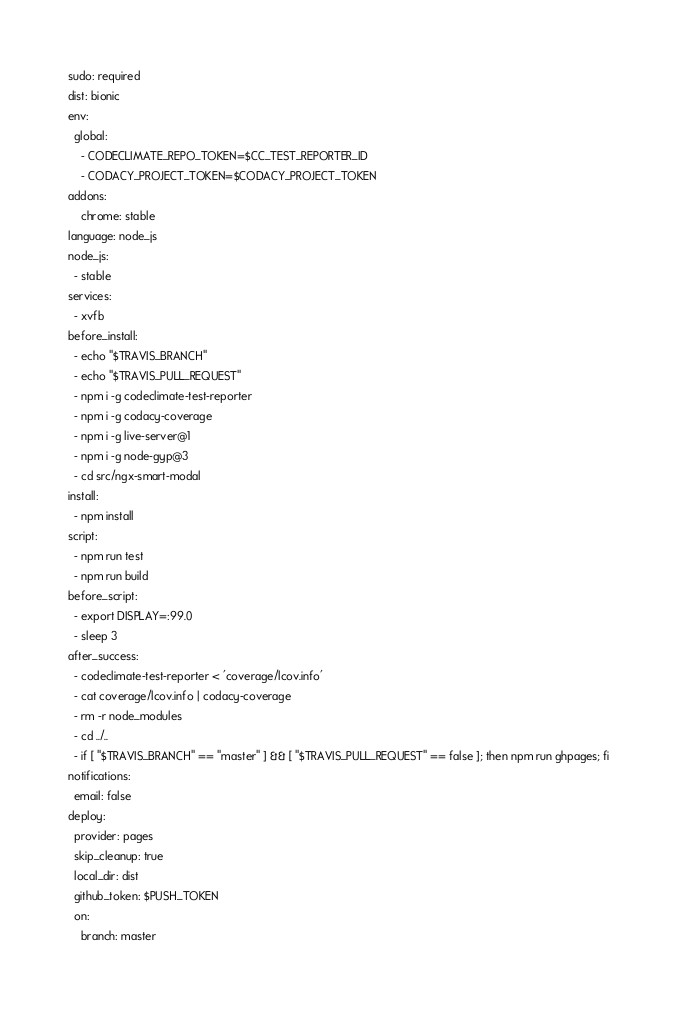<code> <loc_0><loc_0><loc_500><loc_500><_YAML_>sudo: required
dist: bionic
env:
  global:
    - CODECLIMATE_REPO_TOKEN=$CC_TEST_REPORTER_ID
    - CODACY_PROJECT_TOKEN=$CODACY_PROJECT_TOKEN
addons:
    chrome: stable
language: node_js
node_js:
  - stable
services:
  - xvfb
before_install:
  - echo "$TRAVIS_BRANCH"
  - echo "$TRAVIS_PULL_REQUEST"
  - npm i -g codeclimate-test-reporter
  - npm i -g codacy-coverage
  - npm i -g live-server@1
  - npm i -g node-gyp@3
  - cd src/ngx-smart-modal
install:
  - npm install
script:
  - npm run test
  - npm run build
before_script:
  - export DISPLAY=:99.0
  - sleep 3
after_success:
  - codeclimate-test-reporter < 'coverage/lcov.info'
  - cat coverage/lcov.info | codacy-coverage
  - rm -r node_modules
  - cd ../..
  - if [ "$TRAVIS_BRANCH" == "master" ] && [ "$TRAVIS_PULL_REQUEST" == false ]; then npm run ghpages; fi
notifications:
  email: false
deploy:
  provider: pages
  skip_cleanup: true
  local_dir: dist
  github_token: $PUSH_TOKEN
  on:
    branch: master
</code> 